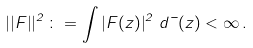Convert formula to latex. <formula><loc_0><loc_0><loc_500><loc_500>\left | \left | F \right | \right | ^ { 2 } \colon = \int \left | F ( z ) \right | ^ { 2 } \, d \mu ( z ) < \infty \, .</formula> 